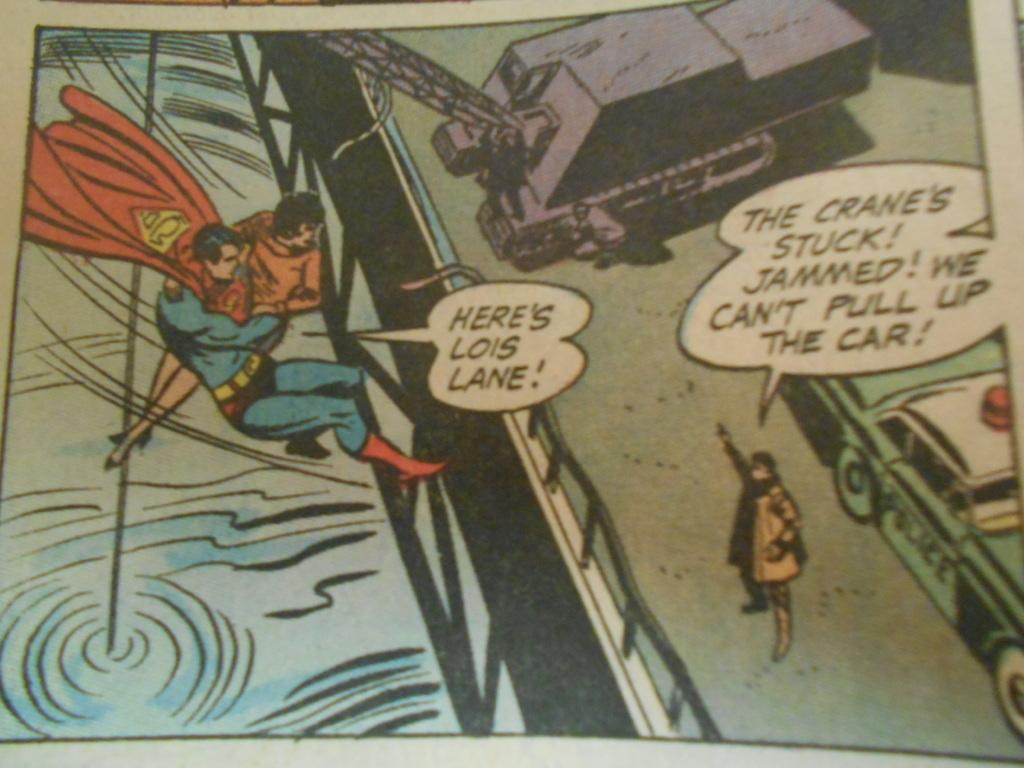<image>
Relay a brief, clear account of the picture shown. a comic book page where someone is saying, 'here's lois lane' 